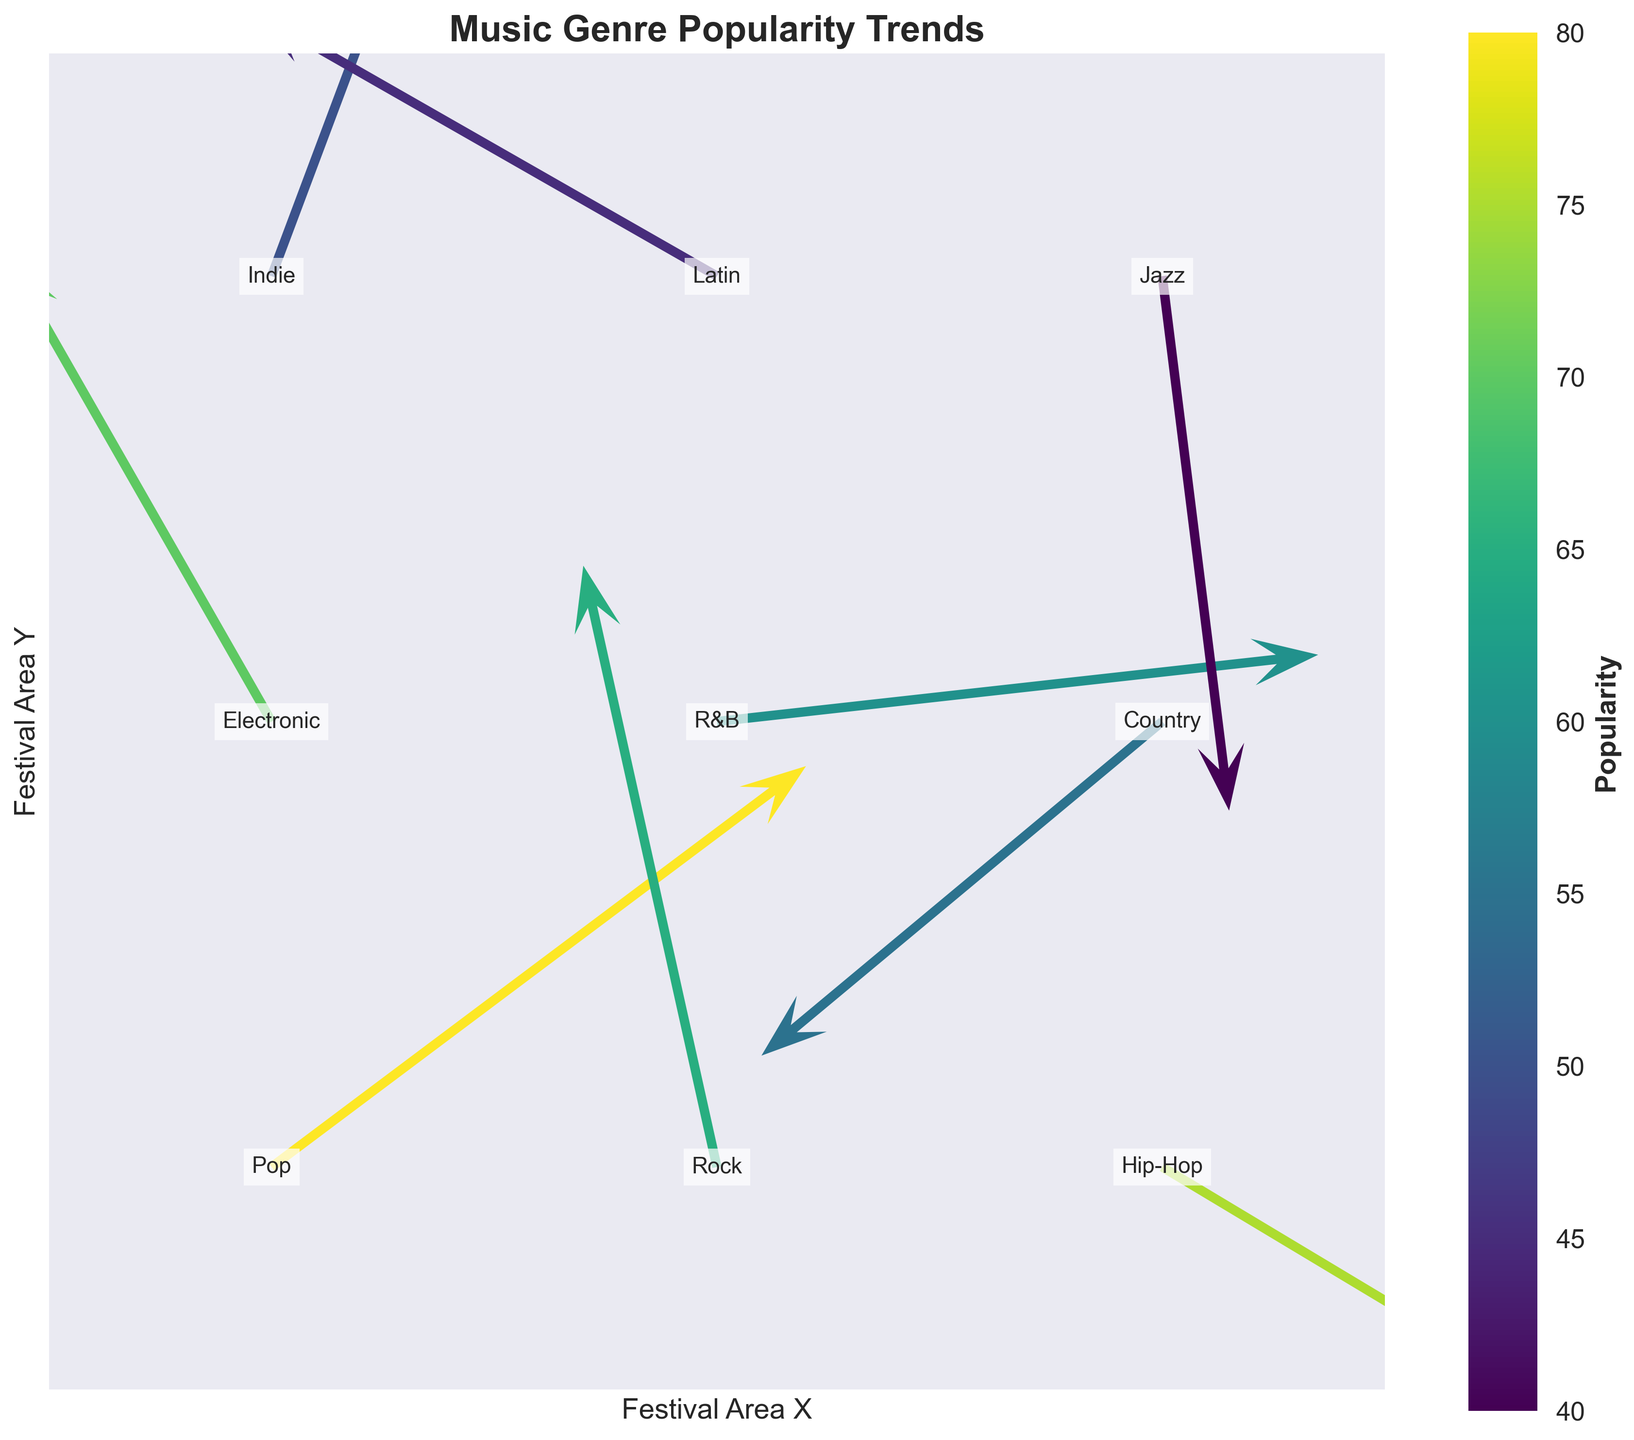What's the title of this figure? The title of the figure is usually found at the top of the plot. It provides a summary of what the plot represents. In this case, it reads "Music Genre Popularity Trends".
Answer: Music Genre Popularity Trends Which genre has the highest popularity? The colorbar indicates popularity with darker colors signifying higher popularity. By examining the color representations, Pop located at (1, 1) has the darkest color.
Answer: Pop What is the trend direction of Rock compared to Pop? The trend direction can be observed from the quiver arrows. Rock at (2, 1) has an arrow pointing upwards to the right, while Pop at (1, 1) has an arrow pointing rightwards up. Evaluating the angles, Rock moves vertically more than horizontally compared to Pop.
Answer: More vertical What is the difference in popularity between the most and least popular genres? The most popular genre is Pop (80) and the least popular is Jazz (40). Subtracting the two gives 80 - 40.
Answer: 40 Which genres are experiencing downward trends in both x and y directions? Downward trends in both directions can be identified by arrows pointing to the bottom-left. Hip-Hop at (3,1) and Country at (3,2) show this downward trend.
Answer: Hip-Hop, Country How does the popularity of Indie compare to that of Latin? By examining their colors and labeling, Indie is at (1,3) with a medium shade, and Latin is at (2,3) with a slightly lighter shade. Indie has a higher popularity (50) compared to Latin (45).
Answer: Higher Which region is experiencing the most divergent trend in x-direction? The steepest x-direction trends are indicated by the longest horizontal arrows. R&B at (2,2) has an arrow pointing rightwards and Latin at (2,3) has an arrow pointing leftwards. Comparing lengths, R&B has a longer arrow.
Answer: R&B What genres show trends towards the right and upwards? Right and upwards-pointing arrows can be seen for Pop (1,1), Indie (1,3), and Electronic (1,2).
Answer: Pop, Indie, Electronic Is there any genre with no movement in any direction? All genres displayed have some directional arrows present. None of the arrows show zero values. Therefore, every genre experiences movement.
Answer: No 